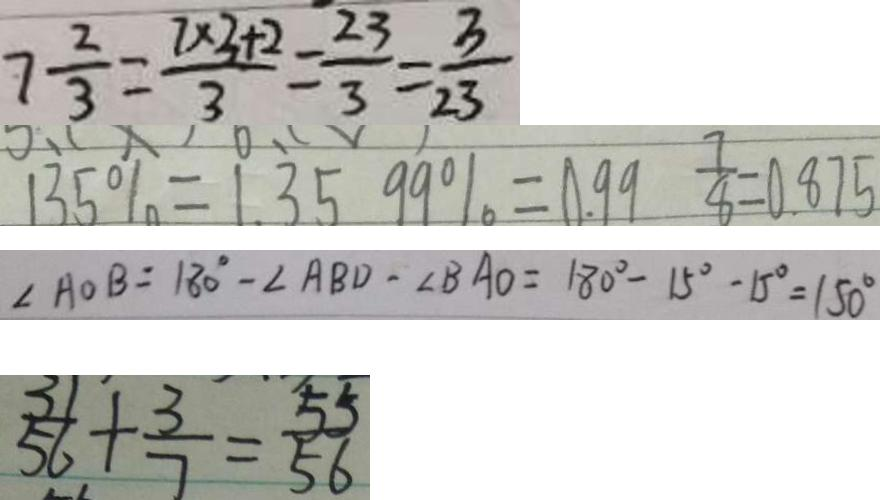<formula> <loc_0><loc_0><loc_500><loc_500>7 \frac { 2 } { 3 } = \frac { 7 \times 3 + 2 } { 3 } = \frac { 2 3 } { 3 } = \frac { 3 } { 2 3 } 
 1 3 5 \% = 1 . 3 5 9 9 \% = 0 . 9 9 \frac { 7 } { 8 } = 0 . 8 7 5 
 \angle A O B = 1 8 0 ^ { \circ } - \angle A B D - \angle B A O = 1 8 0 ^ { \circ } - 1 5 ^ { \circ } - 1 5 ^ { \circ } = 1 5 0 ^ { \circ } 
 \frac { 3 1 } { 5 6 } + \frac { 3 } { 7 } = \frac { 5 5 } { 5 6 }</formula> 